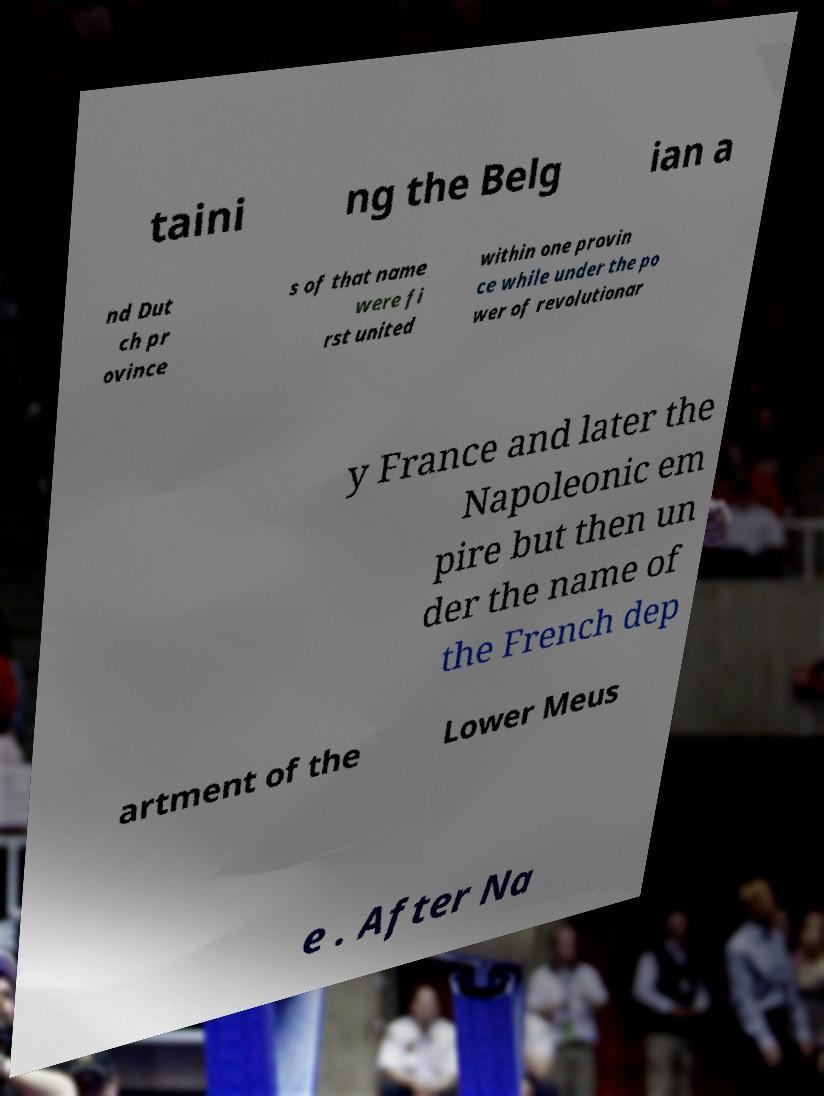For documentation purposes, I need the text within this image transcribed. Could you provide that? taini ng the Belg ian a nd Dut ch pr ovince s of that name were fi rst united within one provin ce while under the po wer of revolutionar y France and later the Napoleonic em pire but then un der the name of the French dep artment of the Lower Meus e . After Na 